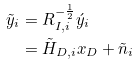Convert formula to latex. <formula><loc_0><loc_0><loc_500><loc_500>\tilde { y } _ { i } & = R _ { I , i } ^ { - \frac { 1 } { 2 } } \acute { y } _ { i } \\ & = \tilde { H } _ { D , i } x _ { D } + \tilde { n } _ { i }</formula> 